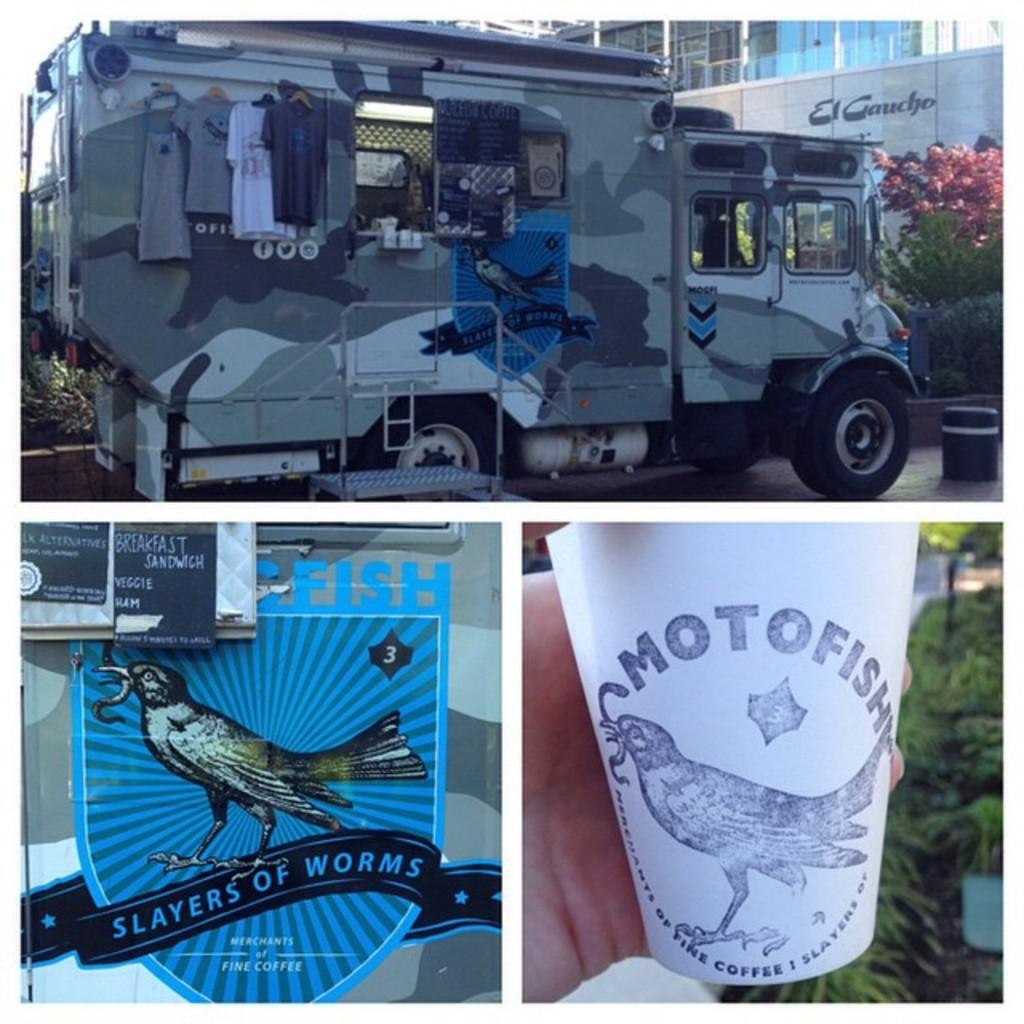Provide a one-sentence caption for the provided image. A military style truck with the brand Slayer of Worms written on the side of it. 